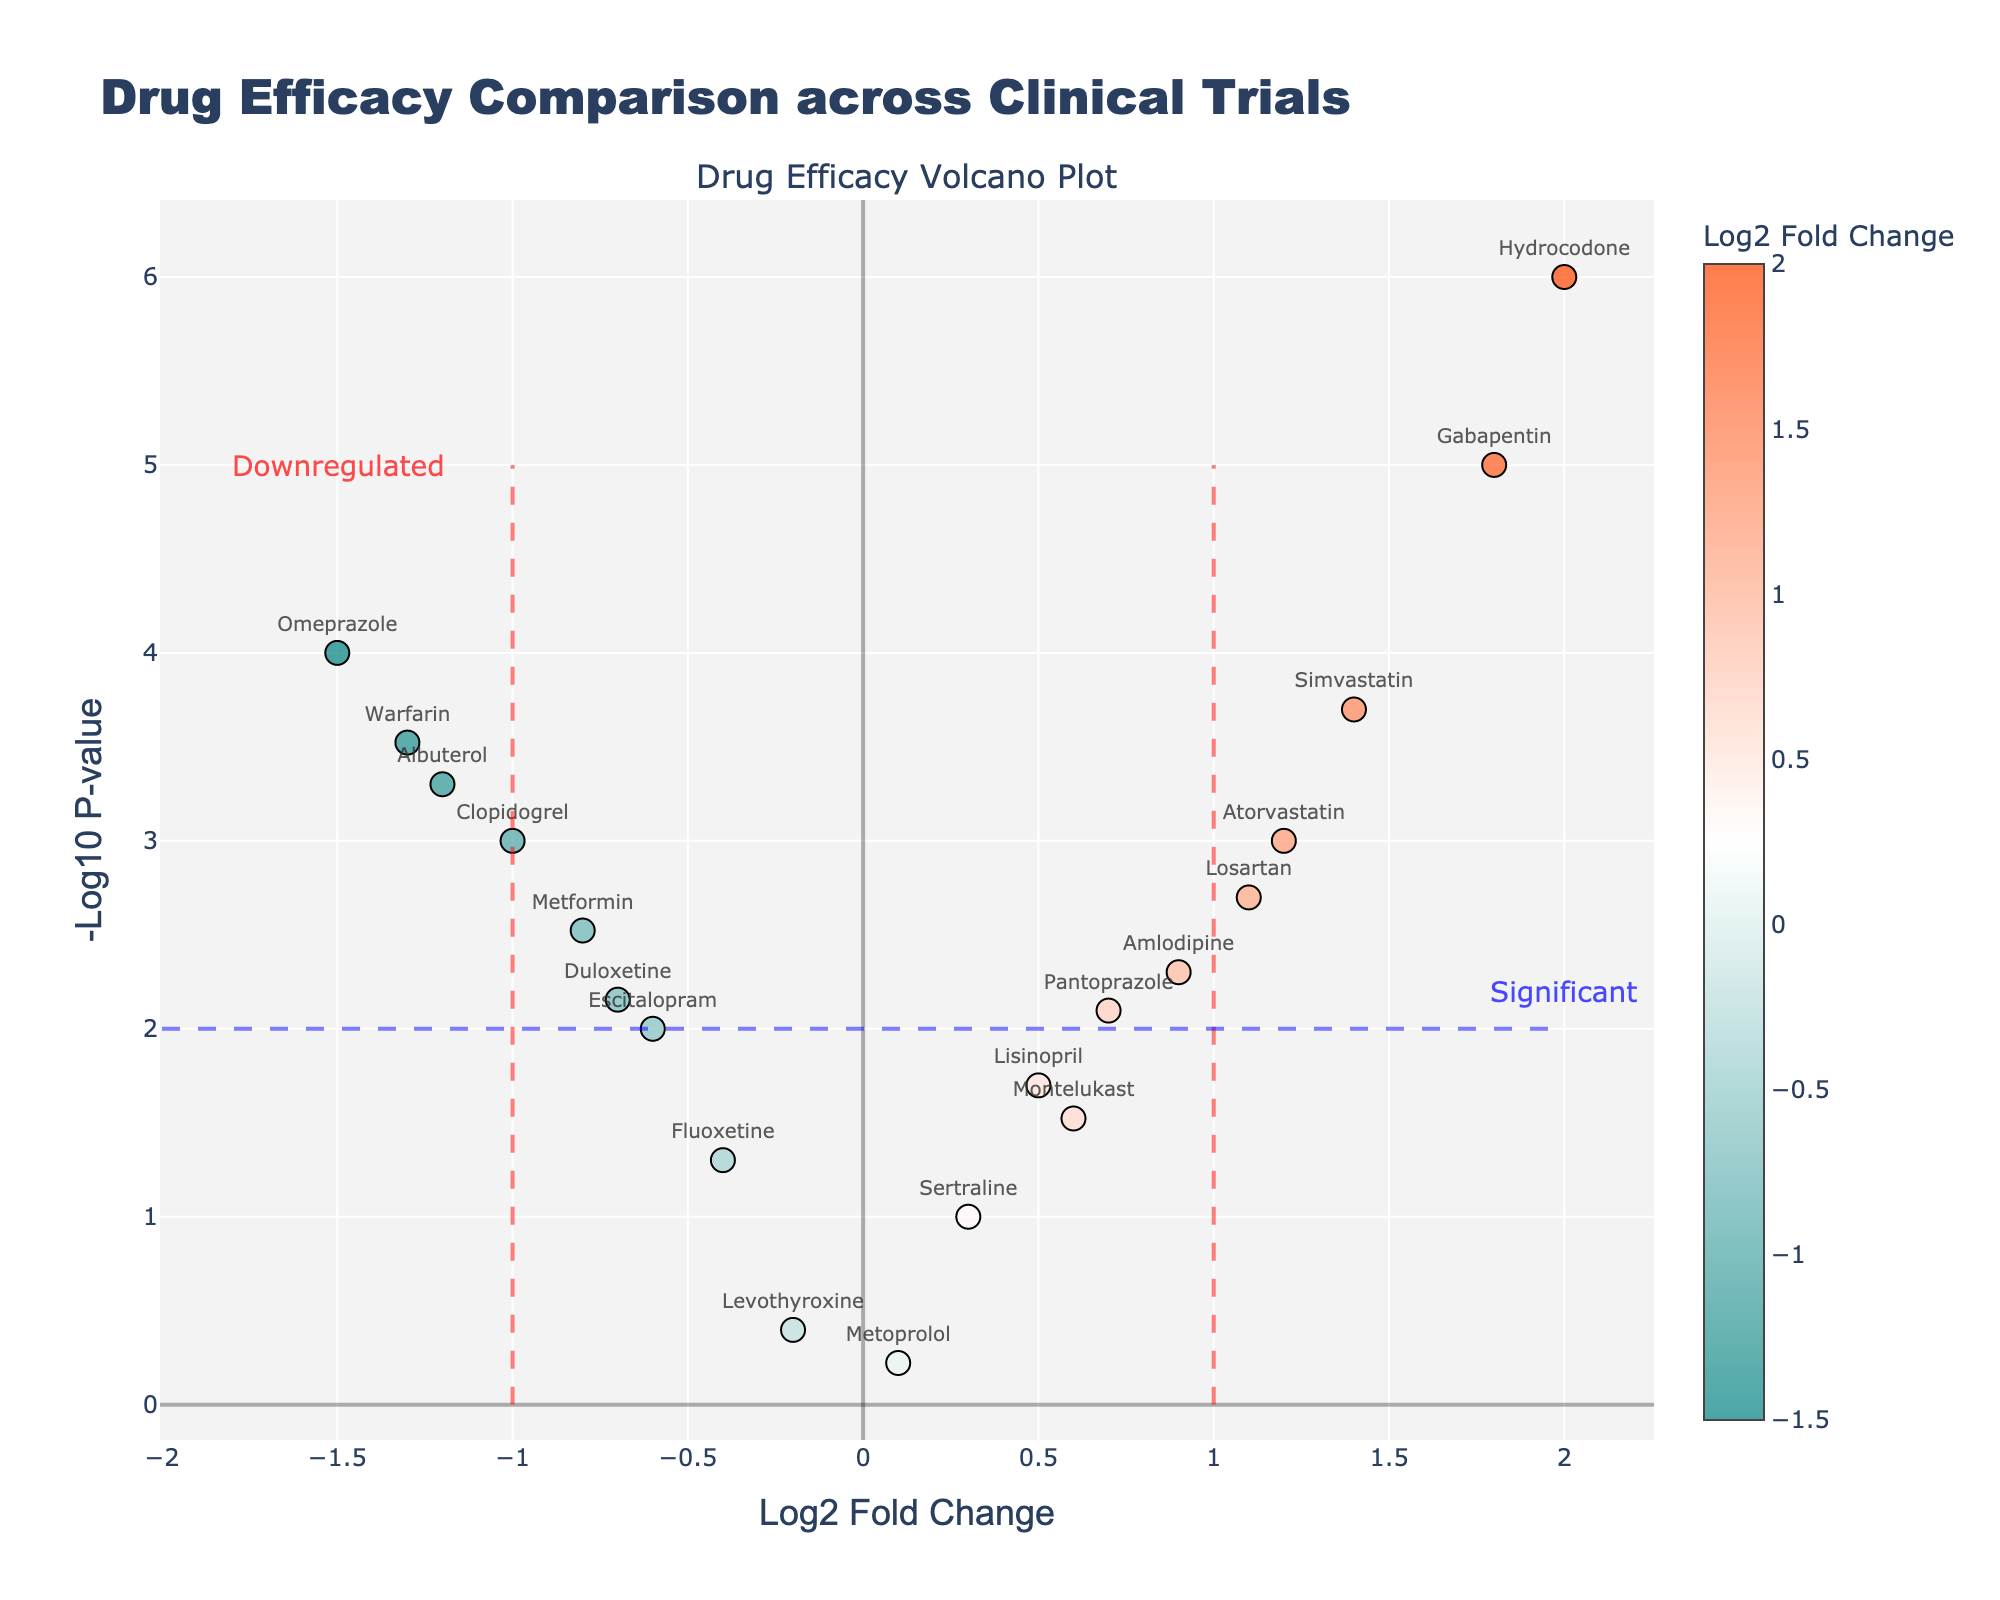What is the title of the figure? The title is visible at the top of the plot, usually in a larger font size and often includes the main subject of the plot.
Answer: Drug Efficacy Comparison across Clinical Trials Which drugs have a Log2 Fold Change greater than 1? To find this, look at the x-axis for points with values greater than 1 and read their corresponding drug names.
Answer: Atorvastatin, Losartan, Simvastatin, Gabapentin, Hydrocodone Which drug has the highest -Log10 P-value? The highest -Log10 P-value corresponds to the point that is the highest on the y-axis.
Answer: Hydrocodone Are there any drugs with a Log2 Fold Change less than -1? To answer this, locate points on the x-axis with values less than -1 and note their corresponding drug names.
Answer: Omeprazole, Albuterol, Clopidogrel, Warfarin Which drug has the lowest -Log10 P-value? The lowest -Log10 P-value corresponds to the point nearest to the x-axis.
Answer: Metoprolol Do any drugs lie exactly on the y-axis (Log2 Fold Change = 0)? Check if there are any points plotted directly on the y-axis where Log2 Fold Change is 0 and name those drugs.
Answer: No Comparing Atorvastatin and Metformin, which one is more significant based on -Log10 P-value? Look at the y-axis values (higher values indicate more significance) for both Atorvastatin and Metformin and compare them.
Answer: Atorvastatin How many drugs show a significant positive fold change (Log2 Fold Change > 1, -Log10 P-value > 2)? Count the number of points that satisfy both Log2 Fold Change > 1 and -Log10 P-value > 2.
Answer: 4 Which drug shows the highest positive Log2 Fold Change? Locate the point furthest to the right on the x-axis (for positive values) and identify the drug name.
Answer: Hydrocodone What does the blue dashed line on the figure represent? The blue dashed line is typically used to indicate a threshold for statistical significance in -Log10 P-value.
Answer: Significance threshold (-Log10 P-value = 2) 